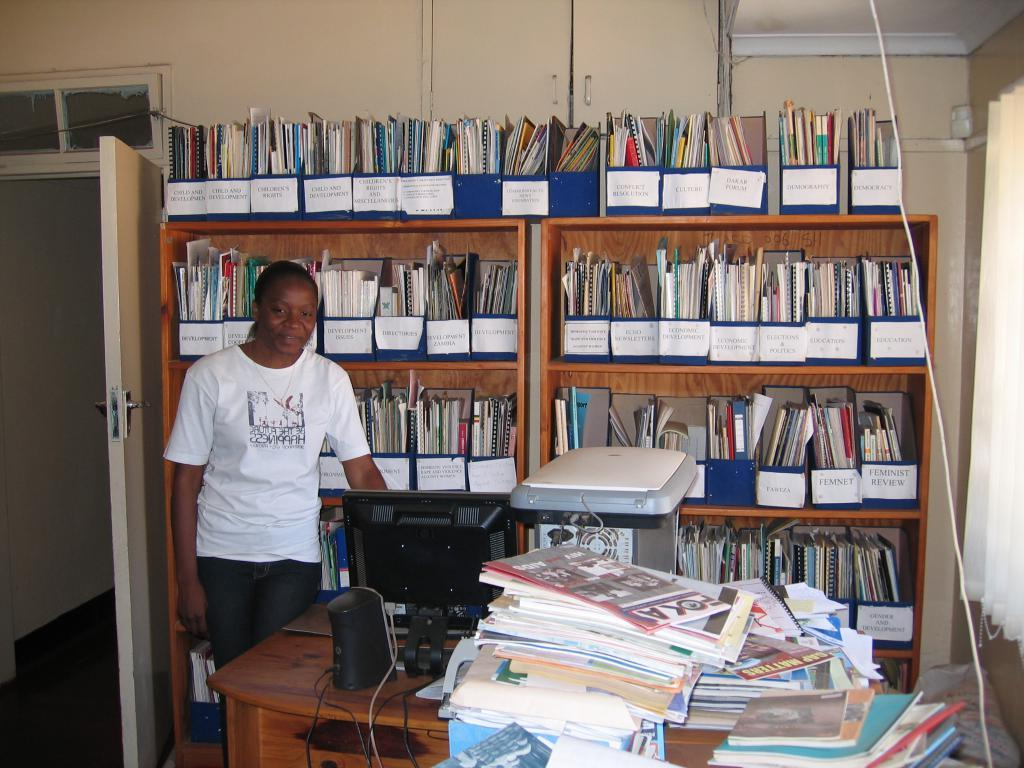<image>
Share a concise interpretation of the image provided. Man wearing a shirt that says Happiness standing in a room with many notebooks. 